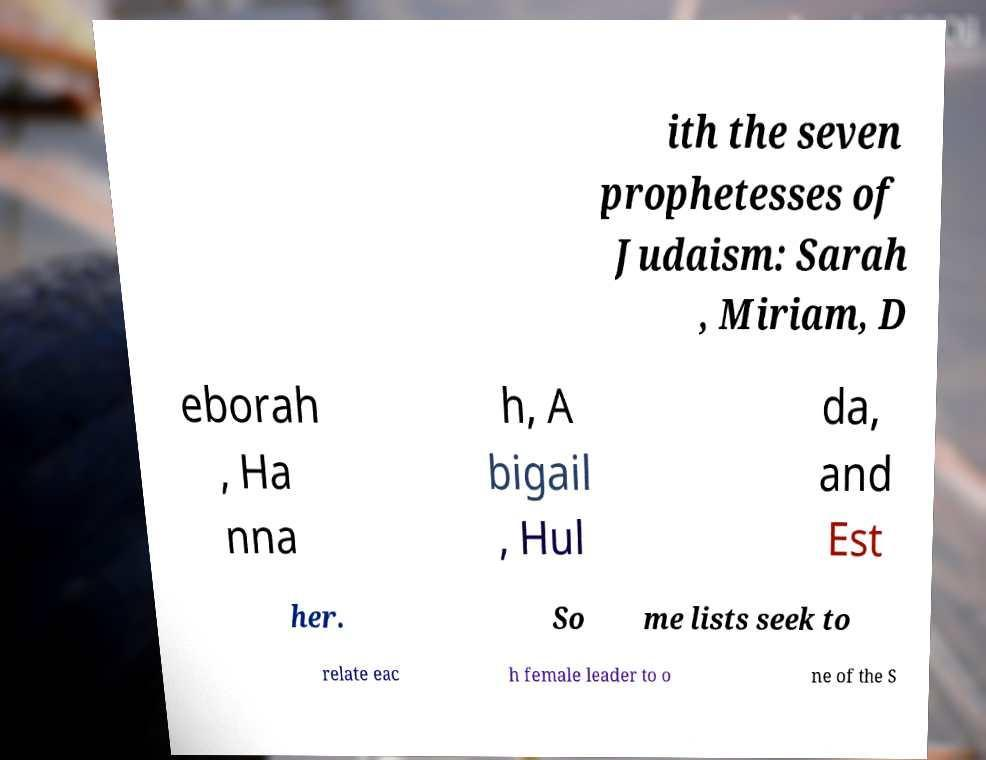For documentation purposes, I need the text within this image transcribed. Could you provide that? ith the seven prophetesses of Judaism: Sarah , Miriam, D eborah , Ha nna h, A bigail , Hul da, and Est her. So me lists seek to relate eac h female leader to o ne of the S 